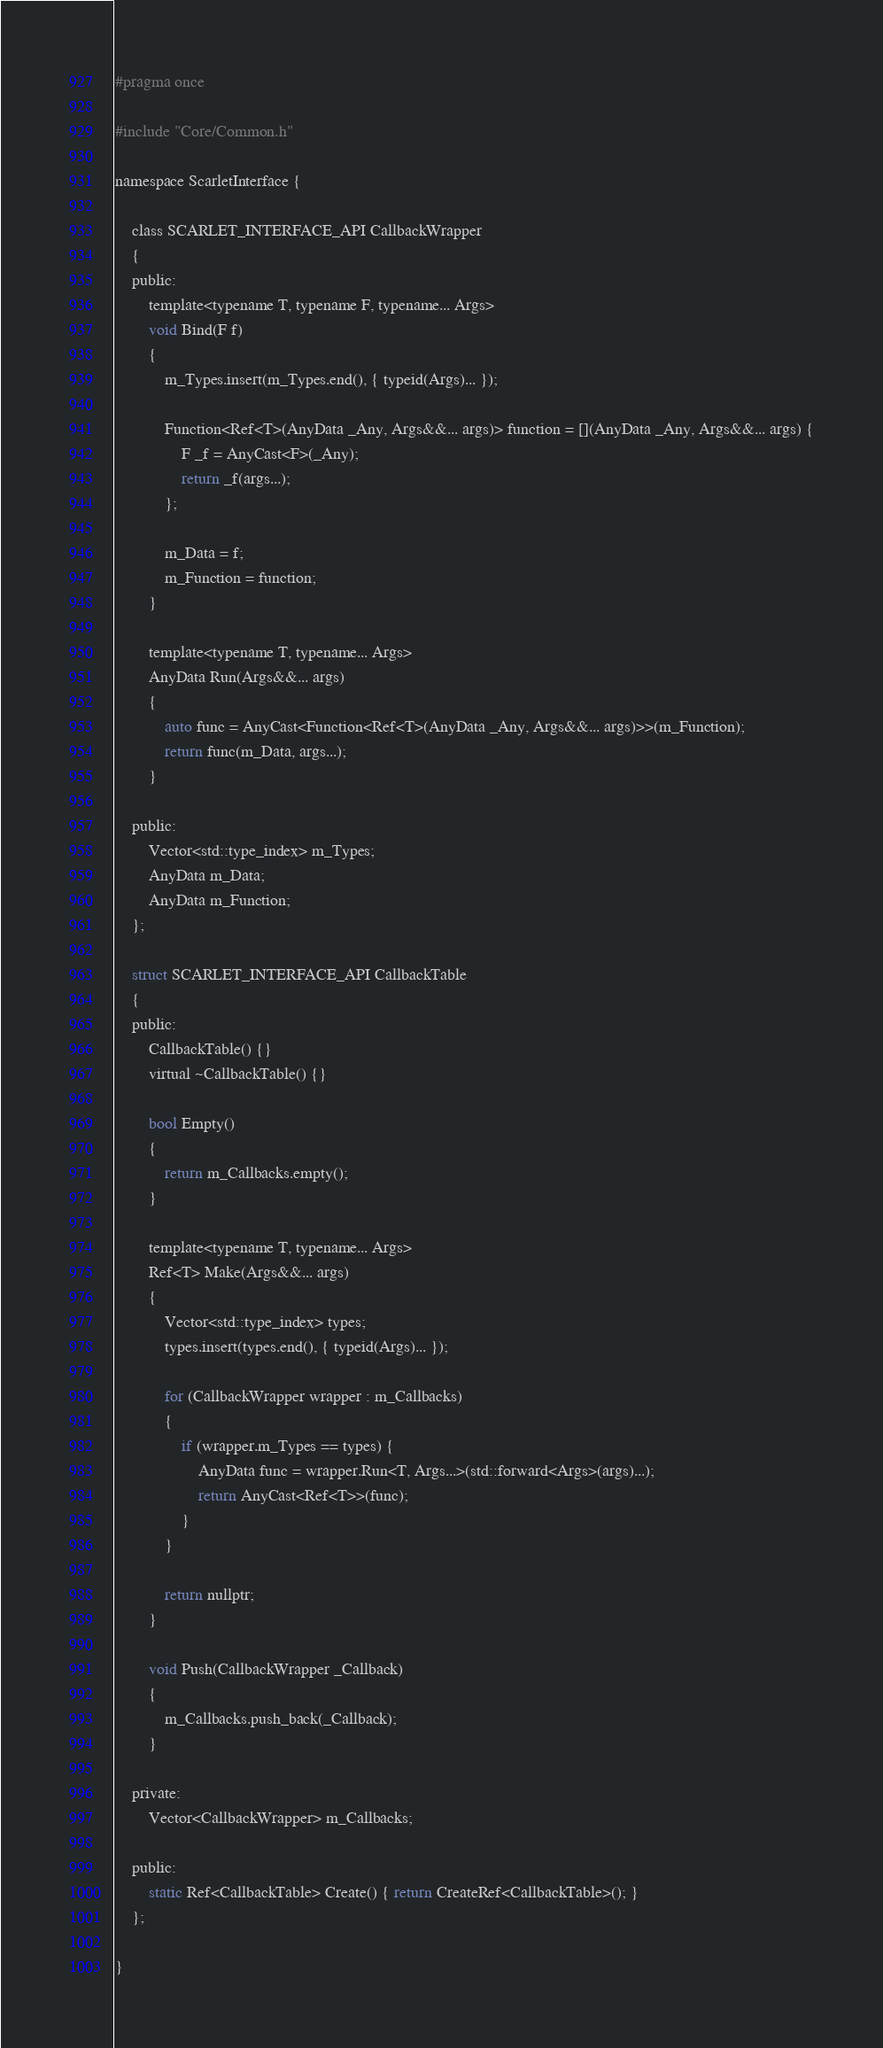<code> <loc_0><loc_0><loc_500><loc_500><_C_>#pragma once

#include "Core/Common.h"

namespace ScarletInterface {

	class SCARLET_INTERFACE_API CallbackWrapper
	{
	public:
		template<typename T, typename F, typename... Args>
		void Bind(F f)
		{
			m_Types.insert(m_Types.end(), { typeid(Args)... });

			Function<Ref<T>(AnyData _Any, Args&&... args)> function = [](AnyData _Any, Args&&... args) {
				F _f = AnyCast<F>(_Any);
				return _f(args...);
			};

			m_Data = f;
			m_Function = function;
		}

		template<typename T, typename... Args>
		AnyData Run(Args&&... args)
		{
			auto func = AnyCast<Function<Ref<T>(AnyData _Any, Args&&... args)>>(m_Function);
			return func(m_Data, args...);
		}

	public:
		Vector<std::type_index> m_Types;
		AnyData m_Data;
		AnyData m_Function;
	};

	struct SCARLET_INTERFACE_API CallbackTable
	{
	public:
		CallbackTable() {}
		virtual ~CallbackTable() {}

		bool Empty()
		{
			return m_Callbacks.empty();
		}

		template<typename T, typename... Args>
		Ref<T> Make(Args&&... args)
		{
			Vector<std::type_index> types;
			types.insert(types.end(), { typeid(Args)... });

			for (CallbackWrapper wrapper : m_Callbacks)
			{
				if (wrapper.m_Types == types) {
					AnyData func = wrapper.Run<T, Args...>(std::forward<Args>(args)...);
					return AnyCast<Ref<T>>(func);
				}
			}

			return nullptr;
		}

		void Push(CallbackWrapper _Callback)
		{
			m_Callbacks.push_back(_Callback);
		}

	private:
		Vector<CallbackWrapper> m_Callbacks;

	public:
		static Ref<CallbackTable> Create() { return CreateRef<CallbackTable>(); }
	};

}</code> 